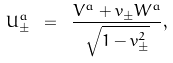Convert formula to latex. <formula><loc_0><loc_0><loc_500><loc_500>U _ { \pm } ^ { a } \ = \ \frac { V ^ { a } + v _ { \pm } W ^ { a } } { \sqrt { 1 - v _ { \pm } ^ { 2 } } } ,</formula> 